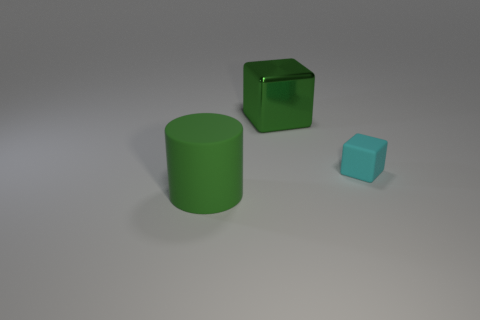Is the big metallic thing the same shape as the cyan object?
Your answer should be compact. Yes. How big is the green thing behind the big green cylinder?
Offer a very short reply. Large. There is a green cylinder; is its size the same as the green object that is on the right side of the big green cylinder?
Keep it short and to the point. Yes. Is the number of cyan rubber cubes to the left of the green block less than the number of big green blocks?
Provide a short and direct response. Yes. What material is the other cyan thing that is the same shape as the large metal thing?
Your answer should be compact. Rubber. What is the shape of the object that is both to the left of the cyan cube and on the right side of the large green matte thing?
Provide a short and direct response. Cube. There is a thing that is the same material as the cylinder; what is its shape?
Keep it short and to the point. Cube. What is the big green object in front of the big metal block made of?
Make the answer very short. Rubber. There is a cube in front of the large green metallic cube; is it the same size as the matte thing to the left of the shiny cube?
Provide a short and direct response. No. The rubber cylinder has what color?
Make the answer very short. Green. 